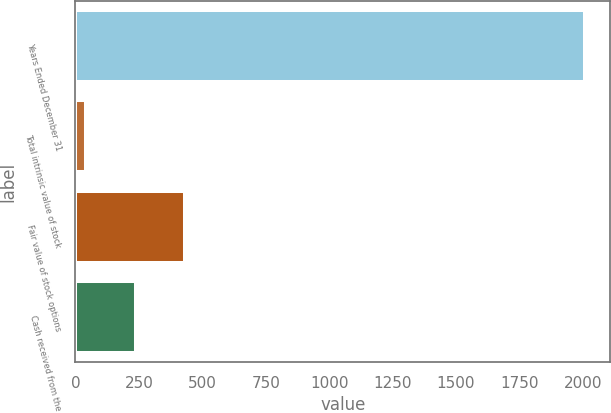<chart> <loc_0><loc_0><loc_500><loc_500><bar_chart><fcel>Years Ended December 31<fcel>Total intrinsic value of stock<fcel>Fair value of stock options<fcel>Cash received from the<nl><fcel>2008<fcel>40.3<fcel>433.84<fcel>237.07<nl></chart> 